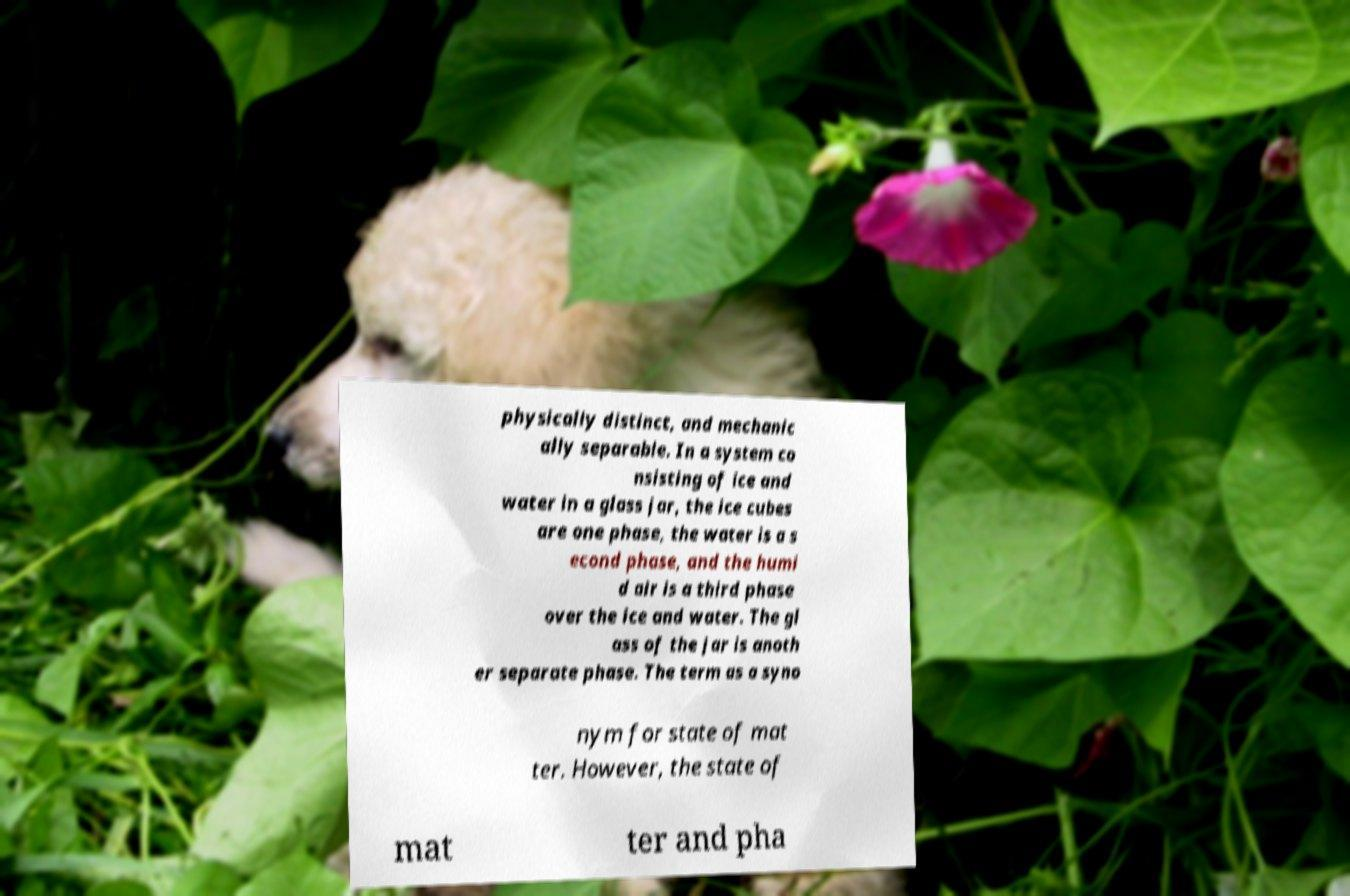For documentation purposes, I need the text within this image transcribed. Could you provide that? physically distinct, and mechanic ally separable. In a system co nsisting of ice and water in a glass jar, the ice cubes are one phase, the water is a s econd phase, and the humi d air is a third phase over the ice and water. The gl ass of the jar is anoth er separate phase. The term as a syno nym for state of mat ter. However, the state of mat ter and pha 